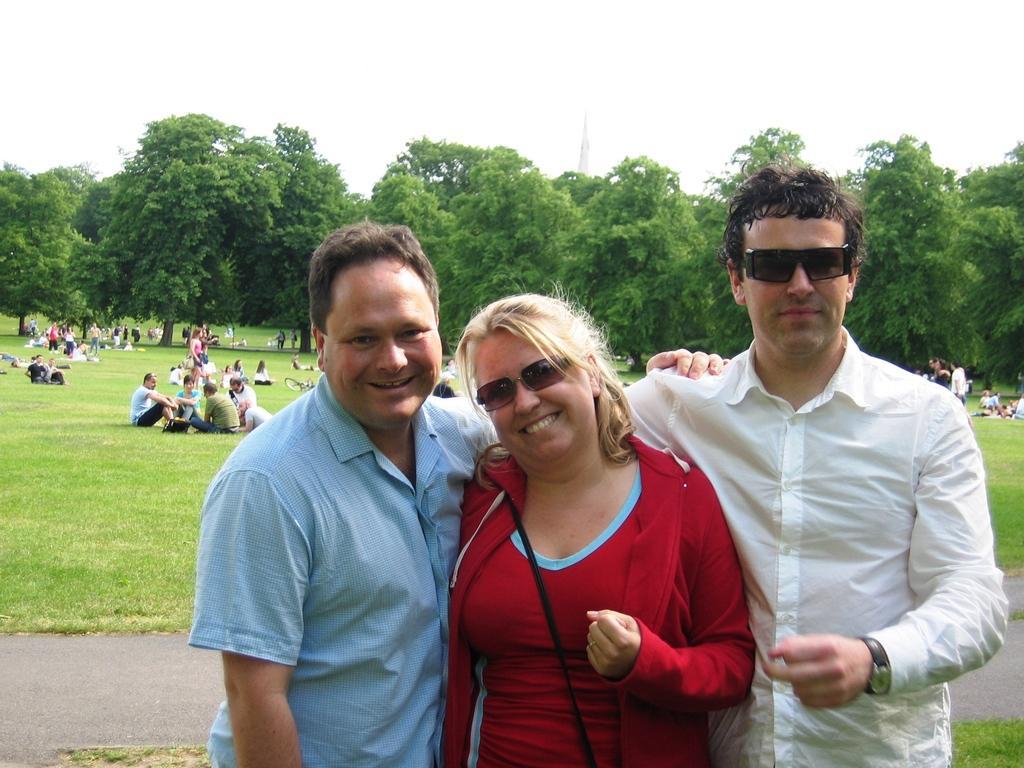Please provide a concise description of this image. In this image we can see men and a woman standing on the ground and smiling. In the background there are people sitting and standing on the ground, trees, tower and sky. 